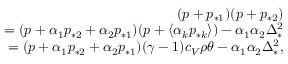Convert formula to latex. <formula><loc_0><loc_0><loc_500><loc_500>\begin{array} { r } { ( p + p _ { * 1 } ) ( p + p _ { * 2 } ) } \\ { = ( p + \alpha _ { 1 } p _ { * 2 } + \alpha _ { 2 } p _ { * 1 } ) ( p + \langle \alpha _ { k } p _ { * k } \rangle ) - \alpha _ { 1 } \alpha _ { 2 } \Delta _ { * } ^ { 2 } } \\ { = ( p + \alpha _ { 1 } p _ { * 2 } + \alpha _ { 2 } p _ { * 1 } ) ( \gamma - 1 ) c _ { V } \rho \theta - \alpha _ { 1 } \alpha _ { 2 } \Delta _ { * } ^ { 2 } , } \end{array}</formula> 